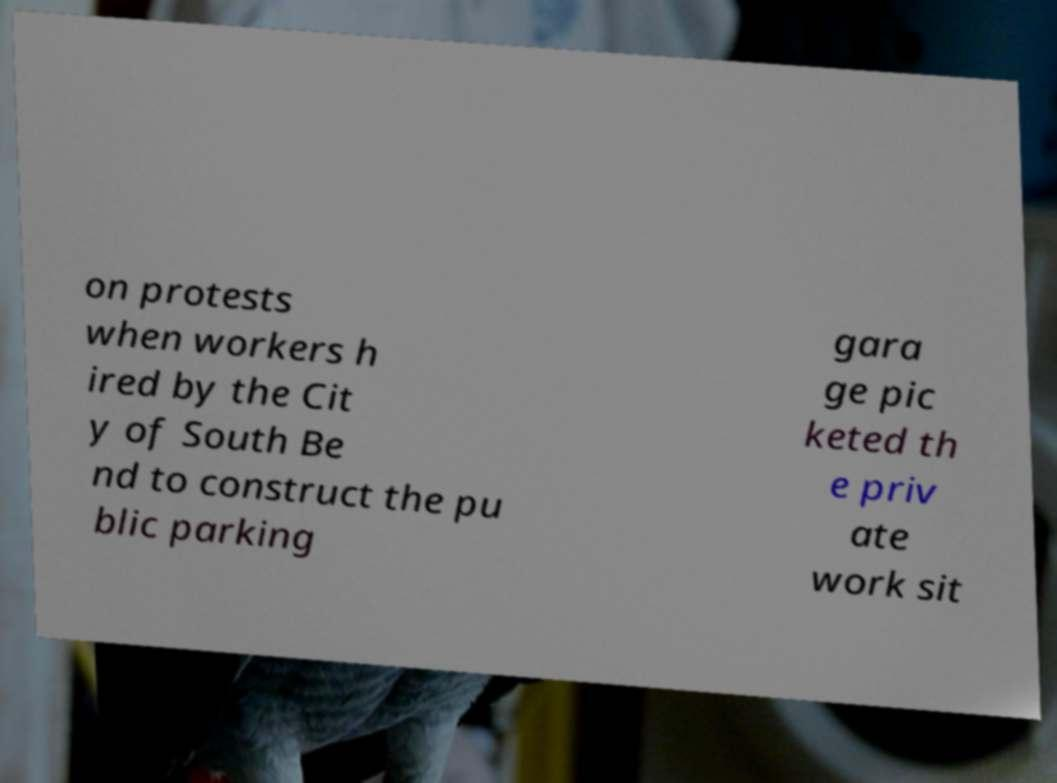For documentation purposes, I need the text within this image transcribed. Could you provide that? on protests when workers h ired by the Cit y of South Be nd to construct the pu blic parking gara ge pic keted th e priv ate work sit 